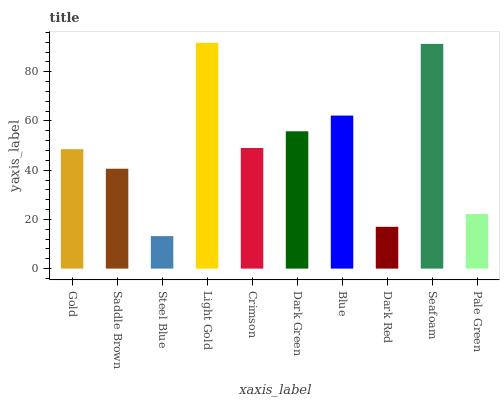Is Steel Blue the minimum?
Answer yes or no. Yes. Is Light Gold the maximum?
Answer yes or no. Yes. Is Saddle Brown the minimum?
Answer yes or no. No. Is Saddle Brown the maximum?
Answer yes or no. No. Is Gold greater than Saddle Brown?
Answer yes or no. Yes. Is Saddle Brown less than Gold?
Answer yes or no. Yes. Is Saddle Brown greater than Gold?
Answer yes or no. No. Is Gold less than Saddle Brown?
Answer yes or no. No. Is Crimson the high median?
Answer yes or no. Yes. Is Gold the low median?
Answer yes or no. Yes. Is Dark Green the high median?
Answer yes or no. No. Is Saddle Brown the low median?
Answer yes or no. No. 